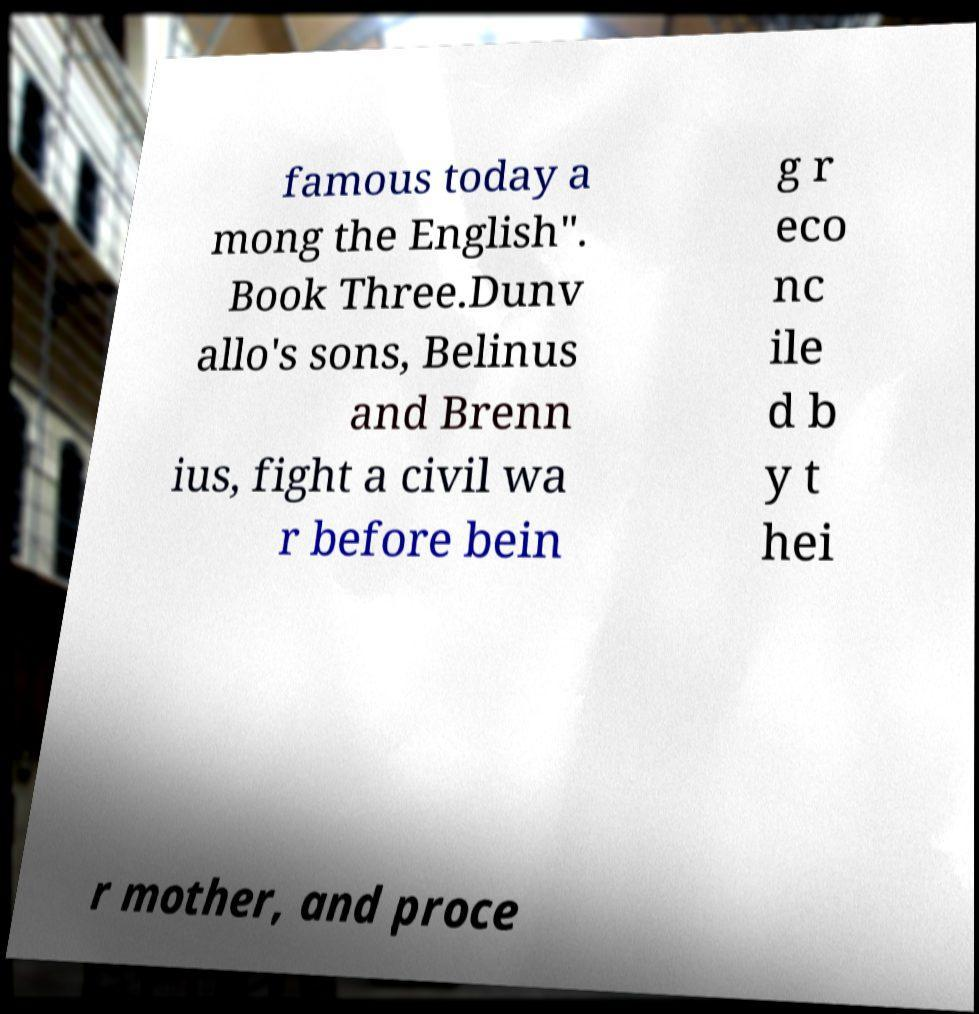Can you read and provide the text displayed in the image?This photo seems to have some interesting text. Can you extract and type it out for me? famous today a mong the English". Book Three.Dunv allo's sons, Belinus and Brenn ius, fight a civil wa r before bein g r eco nc ile d b y t hei r mother, and proce 